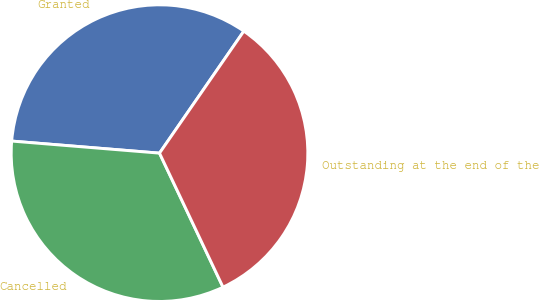<chart> <loc_0><loc_0><loc_500><loc_500><pie_chart><fcel>Granted<fcel>Cancelled<fcel>Outstanding at the end of the<nl><fcel>33.33%<fcel>33.34%<fcel>33.33%<nl></chart> 